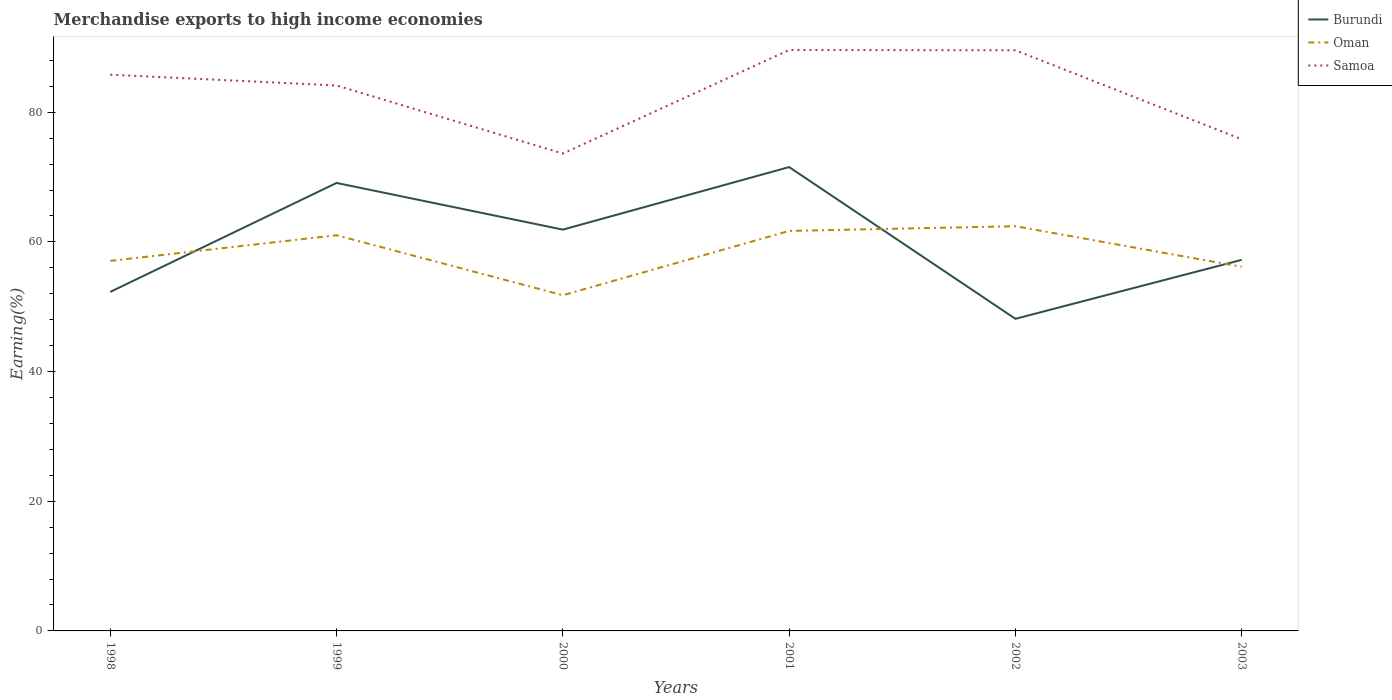How many different coloured lines are there?
Offer a very short reply. 3. Is the number of lines equal to the number of legend labels?
Ensure brevity in your answer.  Yes. Across all years, what is the maximum percentage of amount earned from merchandise exports in Oman?
Offer a terse response. 51.77. What is the total percentage of amount earned from merchandise exports in Samoa in the graph?
Provide a short and direct response. 8.3. What is the difference between the highest and the second highest percentage of amount earned from merchandise exports in Samoa?
Your answer should be compact. 15.97. What is the difference between the highest and the lowest percentage of amount earned from merchandise exports in Burundi?
Make the answer very short. 3. How many years are there in the graph?
Offer a terse response. 6. Are the values on the major ticks of Y-axis written in scientific E-notation?
Make the answer very short. No. Does the graph contain any zero values?
Provide a succinct answer. No. Where does the legend appear in the graph?
Ensure brevity in your answer.  Top right. How many legend labels are there?
Your response must be concise. 3. What is the title of the graph?
Provide a succinct answer. Merchandise exports to high income economies. What is the label or title of the Y-axis?
Your answer should be very brief. Earning(%). What is the Earning(%) in Burundi in 1998?
Your response must be concise. 52.29. What is the Earning(%) of Oman in 1998?
Your answer should be compact. 57.07. What is the Earning(%) in Samoa in 1998?
Offer a very short reply. 85.79. What is the Earning(%) of Burundi in 1999?
Provide a short and direct response. 69.09. What is the Earning(%) of Oman in 1999?
Your response must be concise. 61.03. What is the Earning(%) in Samoa in 1999?
Keep it short and to the point. 84.12. What is the Earning(%) in Burundi in 2000?
Ensure brevity in your answer.  61.89. What is the Earning(%) of Oman in 2000?
Make the answer very short. 51.77. What is the Earning(%) in Samoa in 2000?
Your answer should be compact. 73.62. What is the Earning(%) of Burundi in 2001?
Ensure brevity in your answer.  71.54. What is the Earning(%) in Oman in 2001?
Your response must be concise. 61.69. What is the Earning(%) of Samoa in 2001?
Ensure brevity in your answer.  89.59. What is the Earning(%) of Burundi in 2002?
Provide a succinct answer. 48.14. What is the Earning(%) of Oman in 2002?
Your answer should be compact. 62.42. What is the Earning(%) in Samoa in 2002?
Give a very brief answer. 89.55. What is the Earning(%) in Burundi in 2003?
Ensure brevity in your answer.  57.23. What is the Earning(%) in Oman in 2003?
Make the answer very short. 56.16. What is the Earning(%) of Samoa in 2003?
Provide a succinct answer. 75.82. Across all years, what is the maximum Earning(%) of Burundi?
Give a very brief answer. 71.54. Across all years, what is the maximum Earning(%) in Oman?
Offer a terse response. 62.42. Across all years, what is the maximum Earning(%) of Samoa?
Make the answer very short. 89.59. Across all years, what is the minimum Earning(%) of Burundi?
Offer a terse response. 48.14. Across all years, what is the minimum Earning(%) of Oman?
Offer a terse response. 51.77. Across all years, what is the minimum Earning(%) of Samoa?
Your response must be concise. 73.62. What is the total Earning(%) in Burundi in the graph?
Make the answer very short. 360.18. What is the total Earning(%) of Oman in the graph?
Your response must be concise. 350.14. What is the total Earning(%) in Samoa in the graph?
Offer a very short reply. 498.5. What is the difference between the Earning(%) in Burundi in 1998 and that in 1999?
Your answer should be compact. -16.8. What is the difference between the Earning(%) in Oman in 1998 and that in 1999?
Provide a succinct answer. -3.95. What is the difference between the Earning(%) in Samoa in 1998 and that in 1999?
Offer a very short reply. 1.66. What is the difference between the Earning(%) of Burundi in 1998 and that in 2000?
Keep it short and to the point. -9.6. What is the difference between the Earning(%) in Oman in 1998 and that in 2000?
Your answer should be very brief. 5.3. What is the difference between the Earning(%) of Samoa in 1998 and that in 2000?
Your answer should be very brief. 12.16. What is the difference between the Earning(%) in Burundi in 1998 and that in 2001?
Your answer should be compact. -19.25. What is the difference between the Earning(%) of Oman in 1998 and that in 2001?
Keep it short and to the point. -4.62. What is the difference between the Earning(%) in Samoa in 1998 and that in 2001?
Your response must be concise. -3.81. What is the difference between the Earning(%) of Burundi in 1998 and that in 2002?
Keep it short and to the point. 4.15. What is the difference between the Earning(%) of Oman in 1998 and that in 2002?
Give a very brief answer. -5.34. What is the difference between the Earning(%) of Samoa in 1998 and that in 2002?
Provide a succinct answer. -3.77. What is the difference between the Earning(%) of Burundi in 1998 and that in 2003?
Your answer should be compact. -4.94. What is the difference between the Earning(%) in Oman in 1998 and that in 2003?
Provide a succinct answer. 0.92. What is the difference between the Earning(%) of Samoa in 1998 and that in 2003?
Ensure brevity in your answer.  9.96. What is the difference between the Earning(%) in Burundi in 1999 and that in 2000?
Your answer should be very brief. 7.2. What is the difference between the Earning(%) in Oman in 1999 and that in 2000?
Your response must be concise. 9.25. What is the difference between the Earning(%) in Samoa in 1999 and that in 2000?
Provide a short and direct response. 10.5. What is the difference between the Earning(%) of Burundi in 1999 and that in 2001?
Offer a very short reply. -2.45. What is the difference between the Earning(%) in Oman in 1999 and that in 2001?
Keep it short and to the point. -0.66. What is the difference between the Earning(%) of Samoa in 1999 and that in 2001?
Give a very brief answer. -5.47. What is the difference between the Earning(%) of Burundi in 1999 and that in 2002?
Provide a short and direct response. 20.95. What is the difference between the Earning(%) of Oman in 1999 and that in 2002?
Your answer should be compact. -1.39. What is the difference between the Earning(%) in Samoa in 1999 and that in 2002?
Offer a terse response. -5.43. What is the difference between the Earning(%) of Burundi in 1999 and that in 2003?
Your answer should be compact. 11.86. What is the difference between the Earning(%) in Oman in 1999 and that in 2003?
Make the answer very short. 4.87. What is the difference between the Earning(%) of Samoa in 1999 and that in 2003?
Make the answer very short. 8.3. What is the difference between the Earning(%) of Burundi in 2000 and that in 2001?
Your answer should be very brief. -9.65. What is the difference between the Earning(%) in Oman in 2000 and that in 2001?
Keep it short and to the point. -9.92. What is the difference between the Earning(%) in Samoa in 2000 and that in 2001?
Provide a short and direct response. -15.97. What is the difference between the Earning(%) of Burundi in 2000 and that in 2002?
Keep it short and to the point. 13.76. What is the difference between the Earning(%) of Oman in 2000 and that in 2002?
Offer a very short reply. -10.64. What is the difference between the Earning(%) in Samoa in 2000 and that in 2002?
Ensure brevity in your answer.  -15.93. What is the difference between the Earning(%) of Burundi in 2000 and that in 2003?
Offer a very short reply. 4.66. What is the difference between the Earning(%) of Oman in 2000 and that in 2003?
Keep it short and to the point. -4.39. What is the difference between the Earning(%) in Samoa in 2000 and that in 2003?
Offer a very short reply. -2.2. What is the difference between the Earning(%) in Burundi in 2001 and that in 2002?
Provide a short and direct response. 23.4. What is the difference between the Earning(%) in Oman in 2001 and that in 2002?
Provide a short and direct response. -0.73. What is the difference between the Earning(%) in Samoa in 2001 and that in 2002?
Offer a terse response. 0.04. What is the difference between the Earning(%) of Burundi in 2001 and that in 2003?
Give a very brief answer. 14.31. What is the difference between the Earning(%) in Oman in 2001 and that in 2003?
Ensure brevity in your answer.  5.53. What is the difference between the Earning(%) in Samoa in 2001 and that in 2003?
Ensure brevity in your answer.  13.77. What is the difference between the Earning(%) in Burundi in 2002 and that in 2003?
Your answer should be compact. -9.09. What is the difference between the Earning(%) of Oman in 2002 and that in 2003?
Ensure brevity in your answer.  6.26. What is the difference between the Earning(%) of Samoa in 2002 and that in 2003?
Ensure brevity in your answer.  13.73. What is the difference between the Earning(%) of Burundi in 1998 and the Earning(%) of Oman in 1999?
Your answer should be compact. -8.73. What is the difference between the Earning(%) of Burundi in 1998 and the Earning(%) of Samoa in 1999?
Give a very brief answer. -31.83. What is the difference between the Earning(%) in Oman in 1998 and the Earning(%) in Samoa in 1999?
Your answer should be compact. -27.05. What is the difference between the Earning(%) in Burundi in 1998 and the Earning(%) in Oman in 2000?
Provide a short and direct response. 0.52. What is the difference between the Earning(%) of Burundi in 1998 and the Earning(%) of Samoa in 2000?
Your answer should be compact. -21.33. What is the difference between the Earning(%) of Oman in 1998 and the Earning(%) of Samoa in 2000?
Provide a short and direct response. -16.55. What is the difference between the Earning(%) of Burundi in 1998 and the Earning(%) of Oman in 2001?
Your answer should be very brief. -9.4. What is the difference between the Earning(%) in Burundi in 1998 and the Earning(%) in Samoa in 2001?
Make the answer very short. -37.3. What is the difference between the Earning(%) of Oman in 1998 and the Earning(%) of Samoa in 2001?
Ensure brevity in your answer.  -32.52. What is the difference between the Earning(%) in Burundi in 1998 and the Earning(%) in Oman in 2002?
Your response must be concise. -10.12. What is the difference between the Earning(%) of Burundi in 1998 and the Earning(%) of Samoa in 2002?
Your response must be concise. -37.26. What is the difference between the Earning(%) in Oman in 1998 and the Earning(%) in Samoa in 2002?
Offer a very short reply. -32.48. What is the difference between the Earning(%) in Burundi in 1998 and the Earning(%) in Oman in 2003?
Give a very brief answer. -3.87. What is the difference between the Earning(%) in Burundi in 1998 and the Earning(%) in Samoa in 2003?
Provide a succinct answer. -23.53. What is the difference between the Earning(%) of Oman in 1998 and the Earning(%) of Samoa in 2003?
Make the answer very short. -18.75. What is the difference between the Earning(%) of Burundi in 1999 and the Earning(%) of Oman in 2000?
Provide a succinct answer. 17.32. What is the difference between the Earning(%) of Burundi in 1999 and the Earning(%) of Samoa in 2000?
Keep it short and to the point. -4.53. What is the difference between the Earning(%) in Oman in 1999 and the Earning(%) in Samoa in 2000?
Ensure brevity in your answer.  -12.6. What is the difference between the Earning(%) of Burundi in 1999 and the Earning(%) of Oman in 2001?
Make the answer very short. 7.4. What is the difference between the Earning(%) in Burundi in 1999 and the Earning(%) in Samoa in 2001?
Offer a very short reply. -20.5. What is the difference between the Earning(%) of Oman in 1999 and the Earning(%) of Samoa in 2001?
Offer a terse response. -28.57. What is the difference between the Earning(%) in Burundi in 1999 and the Earning(%) in Oman in 2002?
Your answer should be compact. 6.68. What is the difference between the Earning(%) of Burundi in 1999 and the Earning(%) of Samoa in 2002?
Your response must be concise. -20.46. What is the difference between the Earning(%) of Oman in 1999 and the Earning(%) of Samoa in 2002?
Your answer should be compact. -28.53. What is the difference between the Earning(%) in Burundi in 1999 and the Earning(%) in Oman in 2003?
Your response must be concise. 12.93. What is the difference between the Earning(%) in Burundi in 1999 and the Earning(%) in Samoa in 2003?
Give a very brief answer. -6.73. What is the difference between the Earning(%) of Oman in 1999 and the Earning(%) of Samoa in 2003?
Your answer should be compact. -14.8. What is the difference between the Earning(%) of Burundi in 2000 and the Earning(%) of Oman in 2001?
Give a very brief answer. 0.2. What is the difference between the Earning(%) in Burundi in 2000 and the Earning(%) in Samoa in 2001?
Give a very brief answer. -27.7. What is the difference between the Earning(%) in Oman in 2000 and the Earning(%) in Samoa in 2001?
Provide a short and direct response. -37.82. What is the difference between the Earning(%) in Burundi in 2000 and the Earning(%) in Oman in 2002?
Your response must be concise. -0.52. What is the difference between the Earning(%) in Burundi in 2000 and the Earning(%) in Samoa in 2002?
Your response must be concise. -27.66. What is the difference between the Earning(%) in Oman in 2000 and the Earning(%) in Samoa in 2002?
Offer a terse response. -37.78. What is the difference between the Earning(%) of Burundi in 2000 and the Earning(%) of Oman in 2003?
Offer a terse response. 5.73. What is the difference between the Earning(%) in Burundi in 2000 and the Earning(%) in Samoa in 2003?
Keep it short and to the point. -13.93. What is the difference between the Earning(%) in Oman in 2000 and the Earning(%) in Samoa in 2003?
Provide a short and direct response. -24.05. What is the difference between the Earning(%) of Burundi in 2001 and the Earning(%) of Oman in 2002?
Ensure brevity in your answer.  9.12. What is the difference between the Earning(%) of Burundi in 2001 and the Earning(%) of Samoa in 2002?
Your answer should be very brief. -18.02. What is the difference between the Earning(%) of Oman in 2001 and the Earning(%) of Samoa in 2002?
Keep it short and to the point. -27.86. What is the difference between the Earning(%) in Burundi in 2001 and the Earning(%) in Oman in 2003?
Make the answer very short. 15.38. What is the difference between the Earning(%) in Burundi in 2001 and the Earning(%) in Samoa in 2003?
Your response must be concise. -4.29. What is the difference between the Earning(%) in Oman in 2001 and the Earning(%) in Samoa in 2003?
Provide a short and direct response. -14.13. What is the difference between the Earning(%) of Burundi in 2002 and the Earning(%) of Oman in 2003?
Your answer should be compact. -8.02. What is the difference between the Earning(%) in Burundi in 2002 and the Earning(%) in Samoa in 2003?
Give a very brief answer. -27.69. What is the difference between the Earning(%) in Oman in 2002 and the Earning(%) in Samoa in 2003?
Make the answer very short. -13.41. What is the average Earning(%) of Burundi per year?
Provide a succinct answer. 60.03. What is the average Earning(%) of Oman per year?
Offer a very short reply. 58.36. What is the average Earning(%) of Samoa per year?
Provide a short and direct response. 83.08. In the year 1998, what is the difference between the Earning(%) in Burundi and Earning(%) in Oman?
Offer a terse response. -4.78. In the year 1998, what is the difference between the Earning(%) of Burundi and Earning(%) of Samoa?
Offer a terse response. -33.49. In the year 1998, what is the difference between the Earning(%) in Oman and Earning(%) in Samoa?
Give a very brief answer. -28.71. In the year 1999, what is the difference between the Earning(%) in Burundi and Earning(%) in Oman?
Ensure brevity in your answer.  8.07. In the year 1999, what is the difference between the Earning(%) of Burundi and Earning(%) of Samoa?
Give a very brief answer. -15.03. In the year 1999, what is the difference between the Earning(%) of Oman and Earning(%) of Samoa?
Your answer should be compact. -23.1. In the year 2000, what is the difference between the Earning(%) of Burundi and Earning(%) of Oman?
Your response must be concise. 10.12. In the year 2000, what is the difference between the Earning(%) in Burundi and Earning(%) in Samoa?
Provide a short and direct response. -11.73. In the year 2000, what is the difference between the Earning(%) in Oman and Earning(%) in Samoa?
Provide a succinct answer. -21.85. In the year 2001, what is the difference between the Earning(%) of Burundi and Earning(%) of Oman?
Provide a succinct answer. 9.85. In the year 2001, what is the difference between the Earning(%) of Burundi and Earning(%) of Samoa?
Offer a terse response. -18.05. In the year 2001, what is the difference between the Earning(%) of Oman and Earning(%) of Samoa?
Give a very brief answer. -27.9. In the year 2002, what is the difference between the Earning(%) of Burundi and Earning(%) of Oman?
Keep it short and to the point. -14.28. In the year 2002, what is the difference between the Earning(%) of Burundi and Earning(%) of Samoa?
Give a very brief answer. -41.42. In the year 2002, what is the difference between the Earning(%) of Oman and Earning(%) of Samoa?
Your answer should be very brief. -27.14. In the year 2003, what is the difference between the Earning(%) in Burundi and Earning(%) in Oman?
Your response must be concise. 1.07. In the year 2003, what is the difference between the Earning(%) of Burundi and Earning(%) of Samoa?
Make the answer very short. -18.59. In the year 2003, what is the difference between the Earning(%) in Oman and Earning(%) in Samoa?
Make the answer very short. -19.66. What is the ratio of the Earning(%) of Burundi in 1998 to that in 1999?
Provide a short and direct response. 0.76. What is the ratio of the Earning(%) of Oman in 1998 to that in 1999?
Provide a short and direct response. 0.94. What is the ratio of the Earning(%) of Samoa in 1998 to that in 1999?
Ensure brevity in your answer.  1.02. What is the ratio of the Earning(%) in Burundi in 1998 to that in 2000?
Your answer should be compact. 0.84. What is the ratio of the Earning(%) of Oman in 1998 to that in 2000?
Provide a succinct answer. 1.1. What is the ratio of the Earning(%) of Samoa in 1998 to that in 2000?
Offer a very short reply. 1.17. What is the ratio of the Earning(%) in Burundi in 1998 to that in 2001?
Give a very brief answer. 0.73. What is the ratio of the Earning(%) in Oman in 1998 to that in 2001?
Your response must be concise. 0.93. What is the ratio of the Earning(%) of Samoa in 1998 to that in 2001?
Your response must be concise. 0.96. What is the ratio of the Earning(%) in Burundi in 1998 to that in 2002?
Offer a very short reply. 1.09. What is the ratio of the Earning(%) of Oman in 1998 to that in 2002?
Keep it short and to the point. 0.91. What is the ratio of the Earning(%) of Samoa in 1998 to that in 2002?
Your answer should be very brief. 0.96. What is the ratio of the Earning(%) in Burundi in 1998 to that in 2003?
Give a very brief answer. 0.91. What is the ratio of the Earning(%) in Oman in 1998 to that in 2003?
Provide a succinct answer. 1.02. What is the ratio of the Earning(%) of Samoa in 1998 to that in 2003?
Keep it short and to the point. 1.13. What is the ratio of the Earning(%) of Burundi in 1999 to that in 2000?
Give a very brief answer. 1.12. What is the ratio of the Earning(%) of Oman in 1999 to that in 2000?
Your response must be concise. 1.18. What is the ratio of the Earning(%) in Samoa in 1999 to that in 2000?
Keep it short and to the point. 1.14. What is the ratio of the Earning(%) in Burundi in 1999 to that in 2001?
Offer a very short reply. 0.97. What is the ratio of the Earning(%) in Oman in 1999 to that in 2001?
Offer a very short reply. 0.99. What is the ratio of the Earning(%) in Samoa in 1999 to that in 2001?
Keep it short and to the point. 0.94. What is the ratio of the Earning(%) in Burundi in 1999 to that in 2002?
Give a very brief answer. 1.44. What is the ratio of the Earning(%) in Oman in 1999 to that in 2002?
Make the answer very short. 0.98. What is the ratio of the Earning(%) of Samoa in 1999 to that in 2002?
Your response must be concise. 0.94. What is the ratio of the Earning(%) of Burundi in 1999 to that in 2003?
Offer a very short reply. 1.21. What is the ratio of the Earning(%) of Oman in 1999 to that in 2003?
Offer a terse response. 1.09. What is the ratio of the Earning(%) in Samoa in 1999 to that in 2003?
Make the answer very short. 1.11. What is the ratio of the Earning(%) in Burundi in 2000 to that in 2001?
Your answer should be compact. 0.87. What is the ratio of the Earning(%) in Oman in 2000 to that in 2001?
Your answer should be very brief. 0.84. What is the ratio of the Earning(%) of Samoa in 2000 to that in 2001?
Offer a very short reply. 0.82. What is the ratio of the Earning(%) in Burundi in 2000 to that in 2002?
Provide a succinct answer. 1.29. What is the ratio of the Earning(%) in Oman in 2000 to that in 2002?
Your answer should be very brief. 0.83. What is the ratio of the Earning(%) of Samoa in 2000 to that in 2002?
Provide a short and direct response. 0.82. What is the ratio of the Earning(%) in Burundi in 2000 to that in 2003?
Your answer should be very brief. 1.08. What is the ratio of the Earning(%) of Oman in 2000 to that in 2003?
Offer a terse response. 0.92. What is the ratio of the Earning(%) of Samoa in 2000 to that in 2003?
Your response must be concise. 0.97. What is the ratio of the Earning(%) of Burundi in 2001 to that in 2002?
Ensure brevity in your answer.  1.49. What is the ratio of the Earning(%) of Oman in 2001 to that in 2002?
Give a very brief answer. 0.99. What is the ratio of the Earning(%) of Oman in 2001 to that in 2003?
Your response must be concise. 1.1. What is the ratio of the Earning(%) in Samoa in 2001 to that in 2003?
Your response must be concise. 1.18. What is the ratio of the Earning(%) in Burundi in 2002 to that in 2003?
Keep it short and to the point. 0.84. What is the ratio of the Earning(%) of Oman in 2002 to that in 2003?
Offer a terse response. 1.11. What is the ratio of the Earning(%) of Samoa in 2002 to that in 2003?
Make the answer very short. 1.18. What is the difference between the highest and the second highest Earning(%) in Burundi?
Provide a short and direct response. 2.45. What is the difference between the highest and the second highest Earning(%) in Oman?
Keep it short and to the point. 0.73. What is the difference between the highest and the second highest Earning(%) of Samoa?
Make the answer very short. 0.04. What is the difference between the highest and the lowest Earning(%) in Burundi?
Your answer should be very brief. 23.4. What is the difference between the highest and the lowest Earning(%) of Oman?
Your answer should be compact. 10.64. What is the difference between the highest and the lowest Earning(%) in Samoa?
Give a very brief answer. 15.97. 